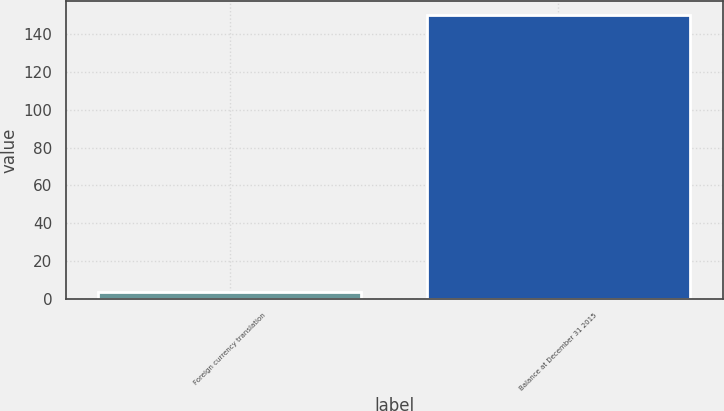Convert chart. <chart><loc_0><loc_0><loc_500><loc_500><bar_chart><fcel>Foreign currency translation<fcel>Balance at December 31 2015<nl><fcel>4<fcel>150<nl></chart> 